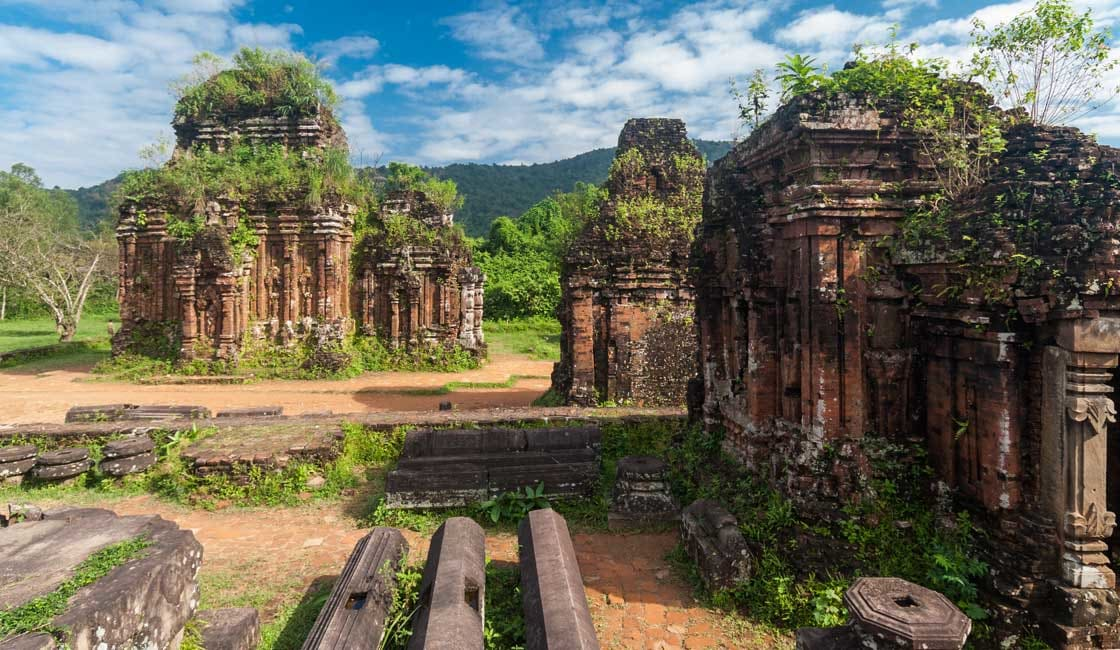How does the architecture reflect the time period in which it was built? The architecture of My Son reflects the distinct Champa style which was influenced by Indian temple architecture, predominantly from the Eastern Indian school of art. The structures are characterized by their tiered towers called 'Kalan,' which symbolize the sacred mountain Meru, considered the center of the universe in Hindu and Buddhist cosmology. The intricate carvings and sculptures found on the temple walls exhibit the artistry and sophistication of Cham craftsmen during that era, particularly the stonework that depicts various Hindu deities, mythical animals, and rituals. The use of baked bricks and intricate reliefs were advanced techniques for the time, indicating a high level of skill in both design and engineering. 